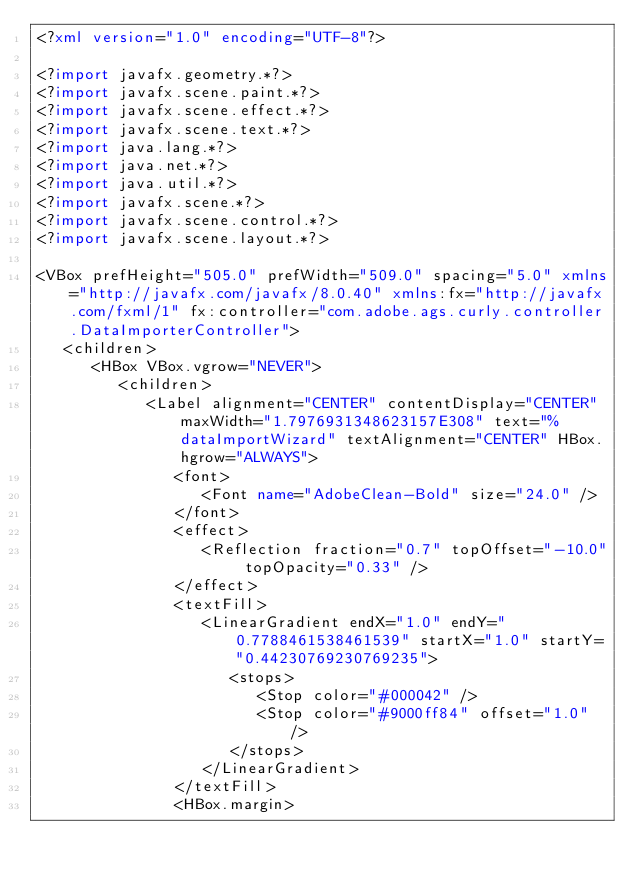Convert code to text. <code><loc_0><loc_0><loc_500><loc_500><_XML_><?xml version="1.0" encoding="UTF-8"?>

<?import javafx.geometry.*?>
<?import javafx.scene.paint.*?>
<?import javafx.scene.effect.*?>
<?import javafx.scene.text.*?>
<?import java.lang.*?>
<?import java.net.*?>
<?import java.util.*?>
<?import javafx.scene.*?>
<?import javafx.scene.control.*?>
<?import javafx.scene.layout.*?>

<VBox prefHeight="505.0" prefWidth="509.0" spacing="5.0" xmlns="http://javafx.com/javafx/8.0.40" xmlns:fx="http://javafx.com/fxml/1" fx:controller="com.adobe.ags.curly.controller.DataImporterController">
   <children>
      <HBox VBox.vgrow="NEVER">
         <children>
            <Label alignment="CENTER" contentDisplay="CENTER" maxWidth="1.7976931348623157E308" text="%dataImportWizard" textAlignment="CENTER" HBox.hgrow="ALWAYS">
               <font>
                  <Font name="AdobeClean-Bold" size="24.0" />
               </font>
               <effect>
                  <Reflection fraction="0.7" topOffset="-10.0" topOpacity="0.33" />
               </effect>
               <textFill>
                  <LinearGradient endX="1.0" endY="0.7788461538461539" startX="1.0" startY="0.44230769230769235">
                     <stops>
                        <Stop color="#000042" />
                        <Stop color="#9000ff84" offset="1.0" />
                     </stops>
                  </LinearGradient>
               </textFill>
               <HBox.margin></code> 